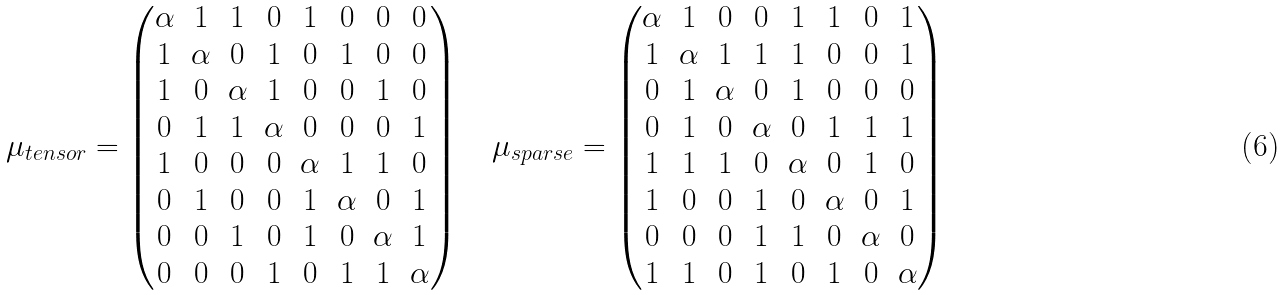Convert formula to latex. <formula><loc_0><loc_0><loc_500><loc_500>\mu _ { t e n s o r } = \begin{pmatrix} \alpha & 1 & 1 & 0 & 1 & 0 & 0 & 0 \\ 1 & \alpha & 0 & 1 & 0 & 1 & 0 & 0 \\ 1 & 0 & \alpha & 1 & 0 & 0 & 1 & 0 \\ 0 & 1 & 1 & \alpha & 0 & 0 & 0 & 1 \\ 1 & 0 & 0 & 0 & \alpha & 1 & 1 & 0 \\ 0 & 1 & 0 & 0 & 1 & \alpha & 0 & 1 \\ 0 & 0 & 1 & 0 & 1 & 0 & \alpha & 1 \\ 0 & 0 & 0 & 1 & 0 & 1 & 1 & \alpha \end{pmatrix} \quad \mu _ { s p a r s e } = \begin{pmatrix} \alpha & 1 & 0 & 0 & 1 & 1 & 0 & 1 \\ 1 & \alpha & 1 & 1 & 1 & 0 & 0 & 1 \\ 0 & 1 & \alpha & 0 & 1 & 0 & 0 & 0 \\ 0 & 1 & 0 & \alpha & 0 & 1 & 1 & 1 \\ 1 & 1 & 1 & 0 & \alpha & 0 & 1 & 0 \\ 1 & 0 & 0 & 1 & 0 & \alpha & 0 & 1 \\ 0 & 0 & 0 & 1 & 1 & 0 & \alpha & 0 \\ 1 & 1 & 0 & 1 & 0 & 1 & 0 & \alpha \end{pmatrix}</formula> 